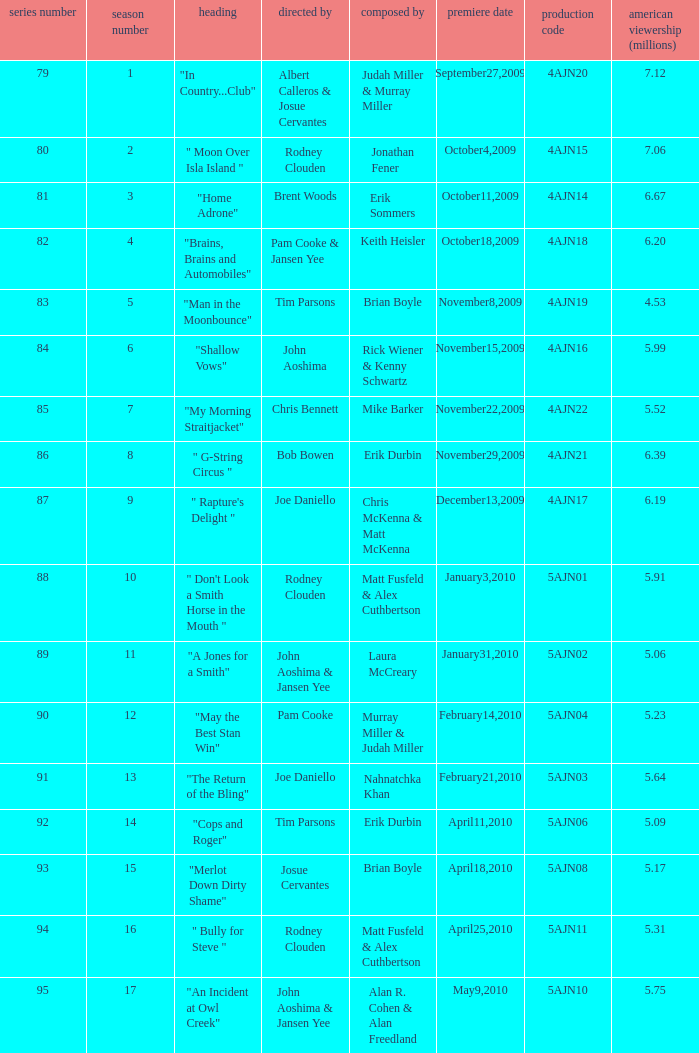Name who wrote number 88 Matt Fusfeld & Alex Cuthbertson. 